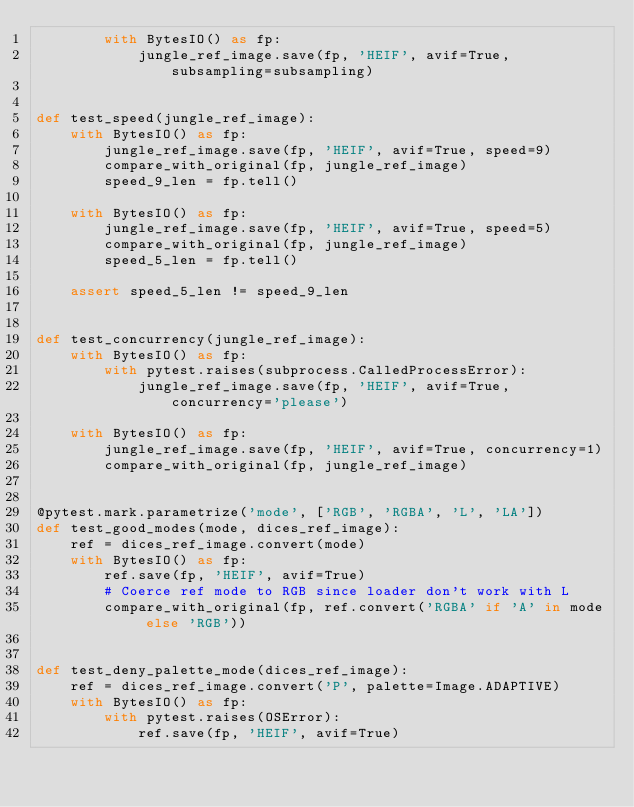Convert code to text. <code><loc_0><loc_0><loc_500><loc_500><_Python_>        with BytesIO() as fp:
            jungle_ref_image.save(fp, 'HEIF', avif=True, subsampling=subsampling)


def test_speed(jungle_ref_image):
    with BytesIO() as fp:
        jungle_ref_image.save(fp, 'HEIF', avif=True, speed=9)
        compare_with_original(fp, jungle_ref_image)
        speed_9_len = fp.tell()

    with BytesIO() as fp:
        jungle_ref_image.save(fp, 'HEIF', avif=True, speed=5)
        compare_with_original(fp, jungle_ref_image)
        speed_5_len = fp.tell()

    assert speed_5_len != speed_9_len


def test_concurrency(jungle_ref_image):
    with BytesIO() as fp:
        with pytest.raises(subprocess.CalledProcessError):
            jungle_ref_image.save(fp, 'HEIF', avif=True, concurrency='please')

    with BytesIO() as fp:
        jungle_ref_image.save(fp, 'HEIF', avif=True, concurrency=1)
        compare_with_original(fp, jungle_ref_image)


@pytest.mark.parametrize('mode', ['RGB', 'RGBA', 'L', 'LA'])
def test_good_modes(mode, dices_ref_image):
    ref = dices_ref_image.convert(mode)
    with BytesIO() as fp:
        ref.save(fp, 'HEIF', avif=True)
        # Coerce ref mode to RGB since loader don't work with L
        compare_with_original(fp, ref.convert('RGBA' if 'A' in mode else 'RGB'))


def test_deny_palette_mode(dices_ref_image):
    ref = dices_ref_image.convert('P', palette=Image.ADAPTIVE)
    with BytesIO() as fp:
        with pytest.raises(OSError):
            ref.save(fp, 'HEIF', avif=True)
</code> 